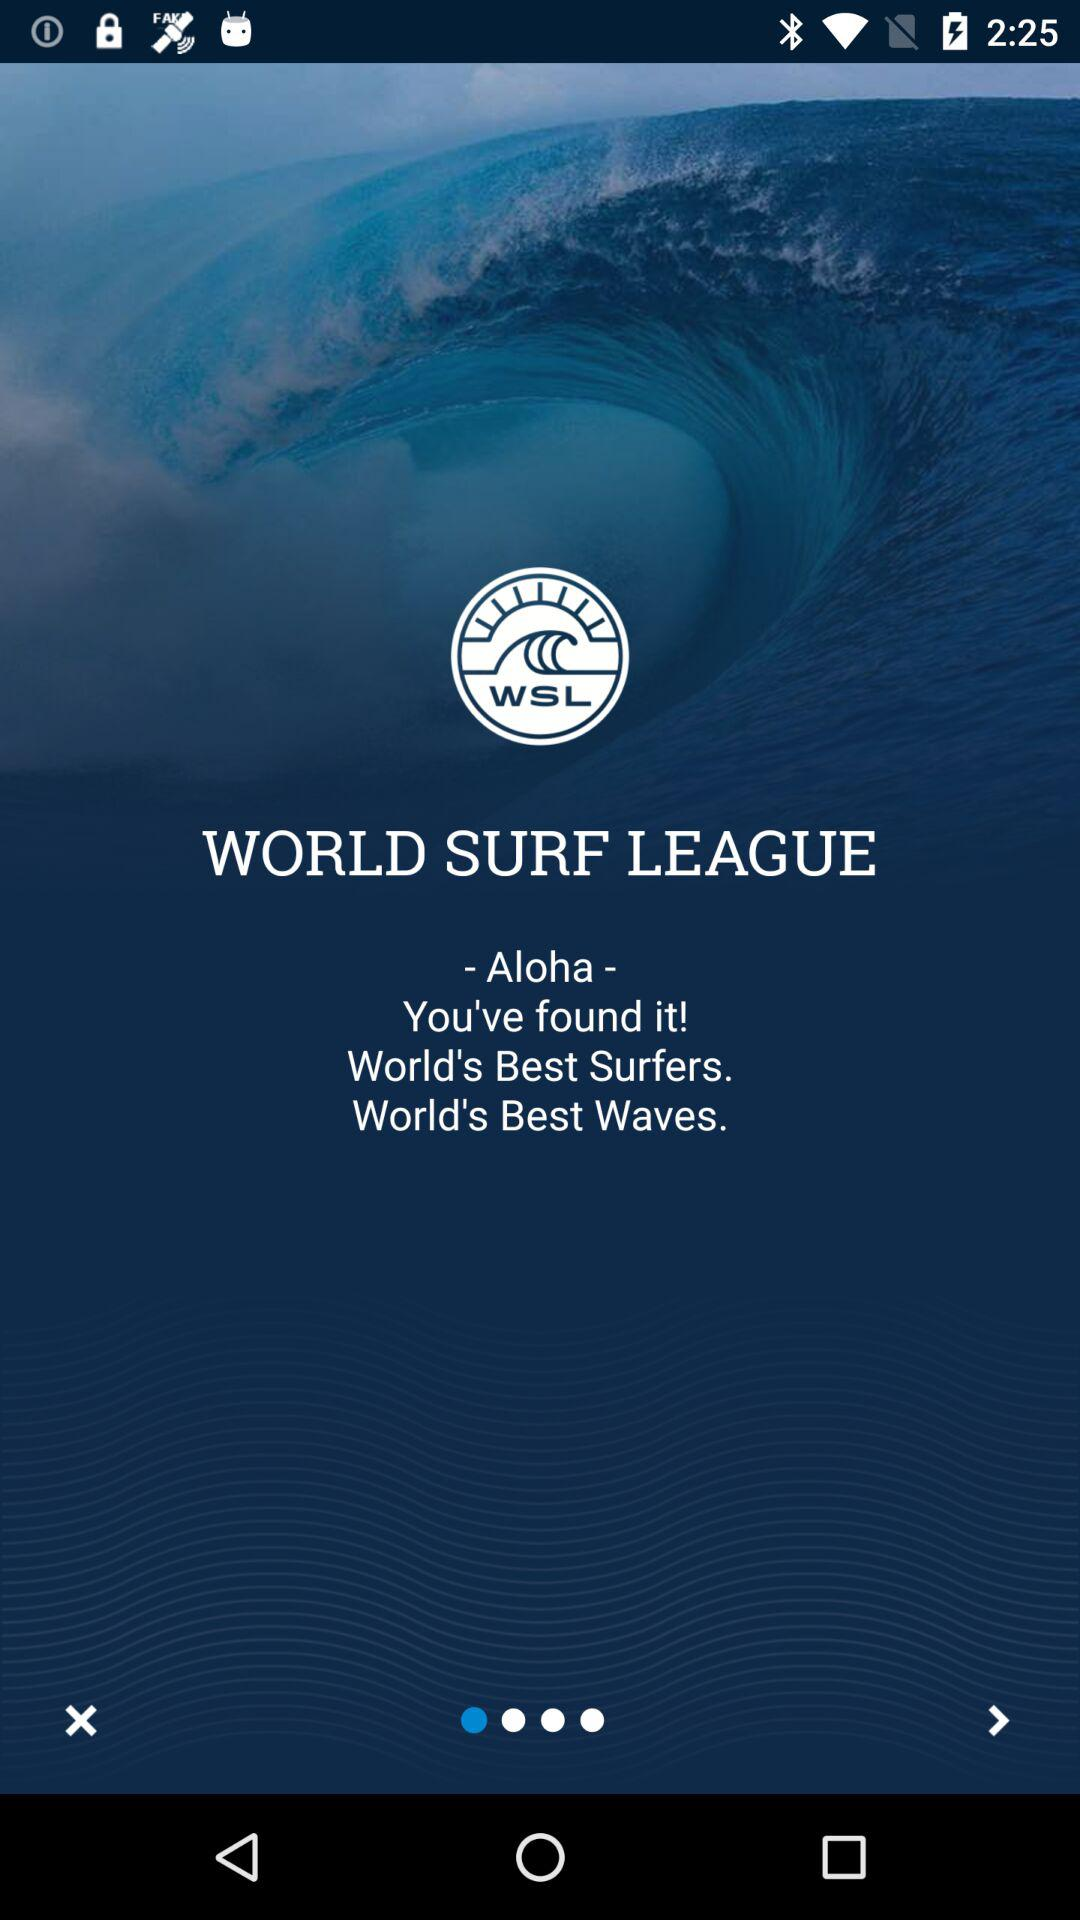What is the app name? The app name is "WORLD SURF LEAGUE". 